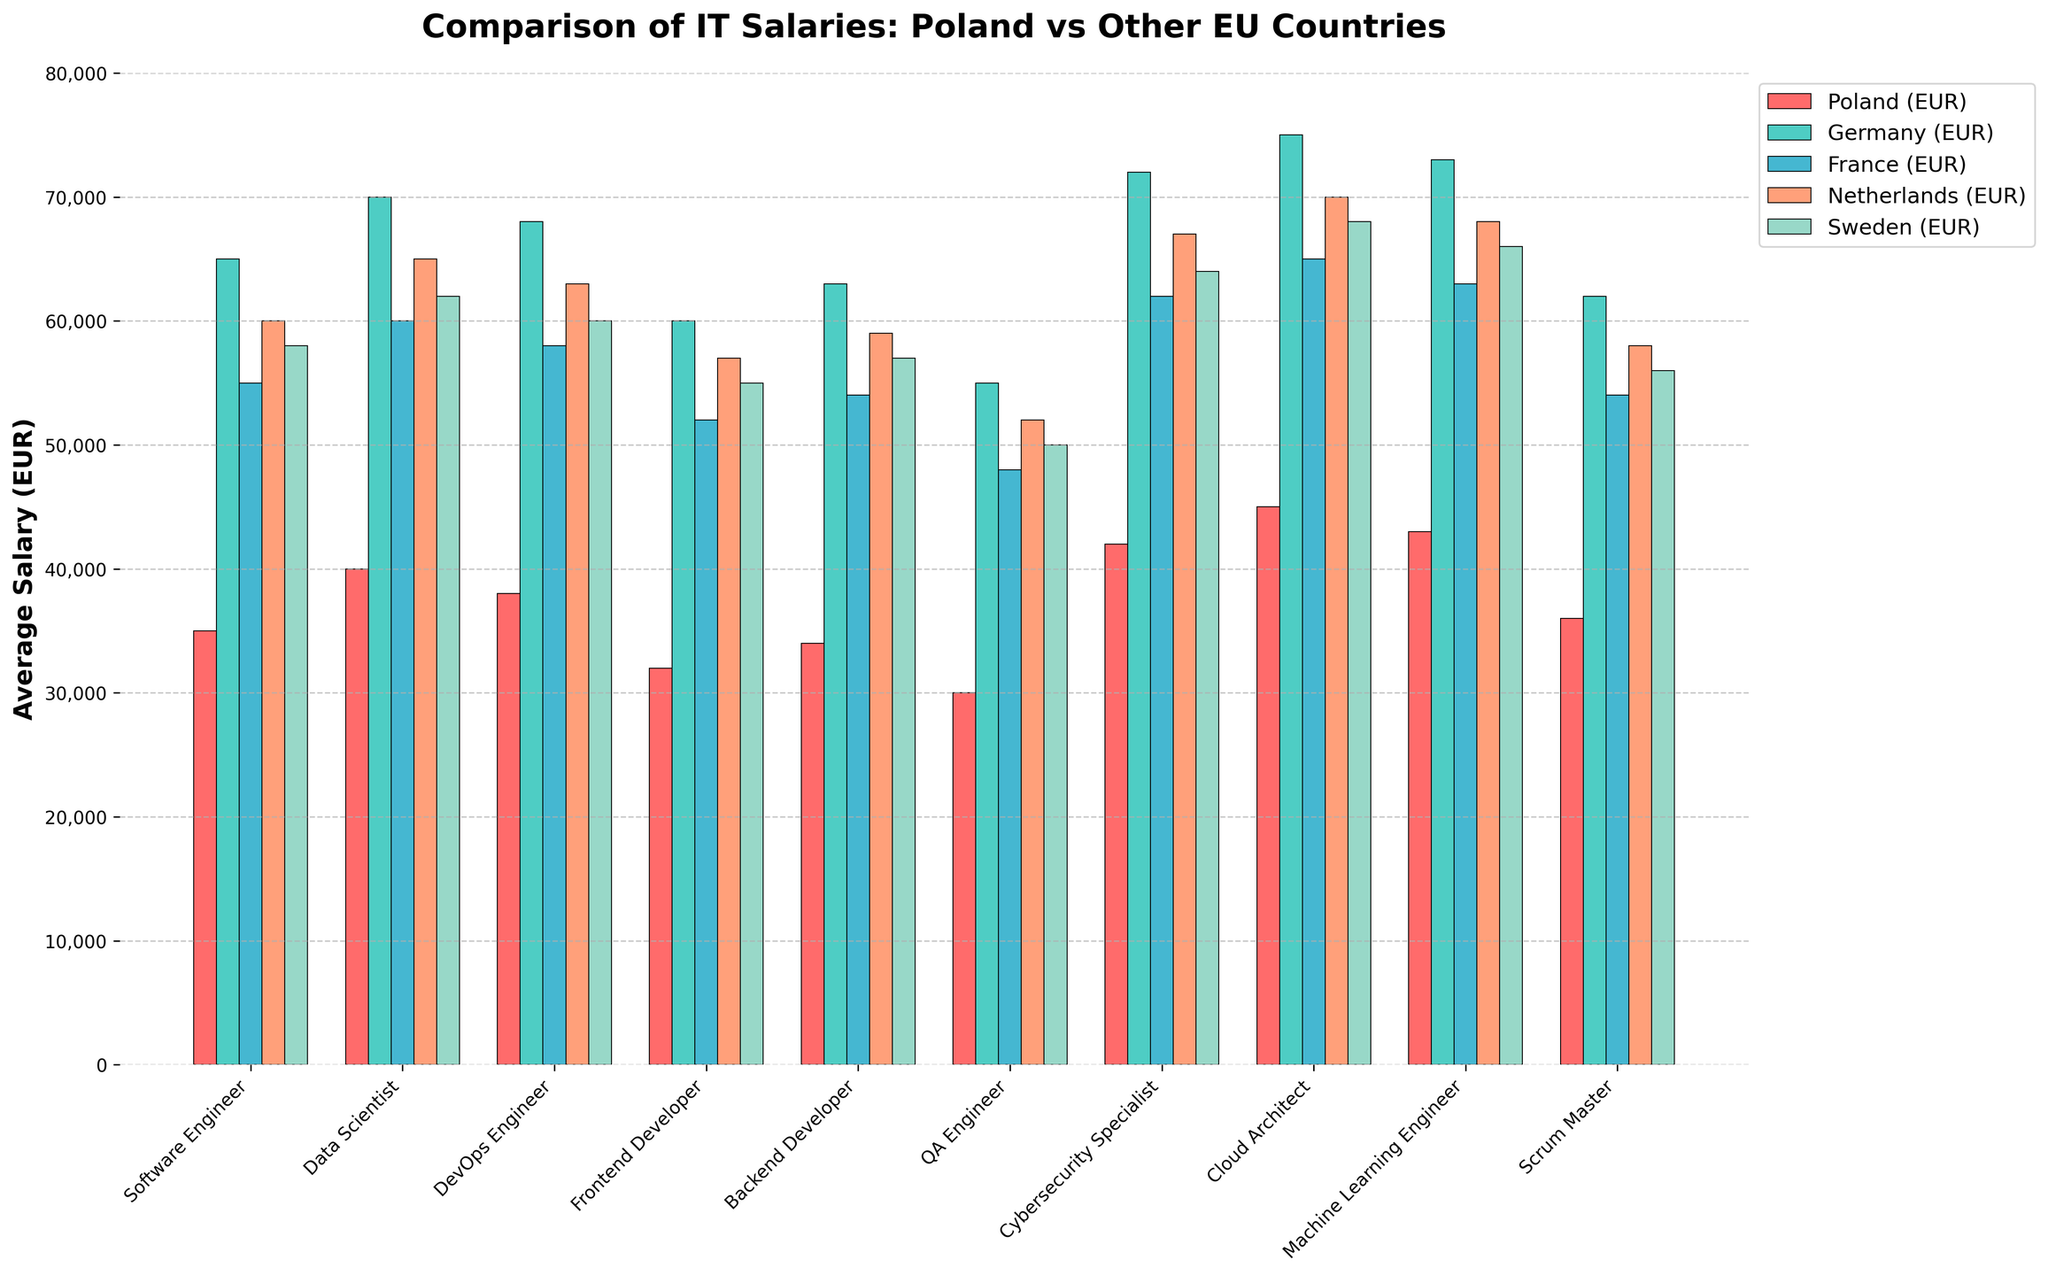What's the highest average salary for any role in Poland? To determine the highest average salary in Poland, look at the Poland (EUR) column and find the maximum value. The roles and their corresponding salaries are listed. The highest salary for Poland is for the Cloud Architect role.
Answer: Cloud Architect: 45,000 EUR Which role shows the largest salary difference between Poland and Germany? Compute the differences between Poland and Germany for each role. The differences are: Software Engineer: 30,000 EUR, Data Scientist: 30,000 EUR, DevOps Engineer: 30,000 EUR, Frontend Developer: 28,000 EUR, Backend Developer: 29,000 EUR, QA Engineer: 25,000 EUR, Cybersecurity Specialist: 30,000 EUR, Cloud Architect: 30,000 EUR, Machine Learning Engineer: 30,000 EUR, Scrum Master: 26,000 EUR. Several roles exhibit a 30,000 EUR difference, such as Software Engineer, Data Scientist, and others.
Answer: Multiple roles: 30,000 EUR How does the average salary for a Data Scientist in Poland compare to the other countries listed? Compare the Data Scientist salary in Poland (40,000 EUR) with those in Germany (70,000 EUR), France (60,000 EUR), Netherlands (65,000 EUR), and Sweden (62,000 EUR). The salary in Poland is the lowest among the listed countries.
Answer: Lowest in Poland For which role is the average salary in France closest to Poland? Look at the differences in salaries between France and Poland for each role. The differences are: Software Engineer: 20,000 EUR, Data Scientist: 20,000 EUR, DevOps Engineer: 20,000 EUR, Frontend Developer: 20,000 EUR, Backend Developer: 20,000 EUR, QA Engineer: 18,000 EUR, Cybersecurity Specialist: 20,000 EUR, Cloud Architect: 20,000 EUR, Machine Learning Engineer: 20,000 EUR, Scrum Master: 18,000 EUR. The QA Engineer and Scrum Master roles have the smallest difference of 18,000 EUR.
Answer: QA Engineer and Scrum Master What is the average salary of DevOps Engineers across Poland, Germany, France, Netherlands, and Sweden? Add the salaries for DevOps Engineers in each country and divide by the number of countries: (38,000 + 68,000 + 58,000 + 63,000 + 60,000) / 5 = 57,400 EUR.
Answer: 57,400 EUR How much more is a Cloud Architect in the Netherlands paid compared to Poland? Subtract the salary in Poland from the salary in the Netherlands for Cloud Architects: 70,000 EUR - 45,000 EUR = 25,000 EUR.
Answer: 25,000 EUR Which country pays the highest average salary for Software Engineers? Look at the salaries for Software Engineers across all countries and identify the highest value. Germany offers the highest average salary for Software Engineers at 65,000 EUR.
Answer: Germany: 65,000 EUR What is the difference in average salary for Backend Developers between Sweden and Poland? Subtract the Poland salary from the Sweden salary for Backend Developers: 57,000 EUR - 34,000 EUR = 23,000 EUR.
Answer: 23,000 EUR 